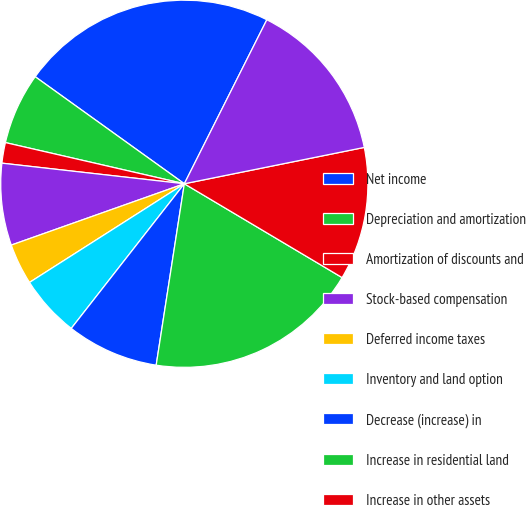Convert chart to OTSL. <chart><loc_0><loc_0><loc_500><loc_500><pie_chart><fcel>Net income<fcel>Depreciation and amortization<fcel>Amortization of discounts and<fcel>Stock-based compensation<fcel>Deferred income taxes<fcel>Inventory and land option<fcel>Decrease (increase) in<fcel>Increase in residential land<fcel>Increase in other assets<fcel>Net (increase) decrease in<nl><fcel>22.51%<fcel>6.31%<fcel>1.81%<fcel>7.21%<fcel>3.61%<fcel>5.41%<fcel>8.11%<fcel>18.91%<fcel>11.71%<fcel>14.41%<nl></chart> 